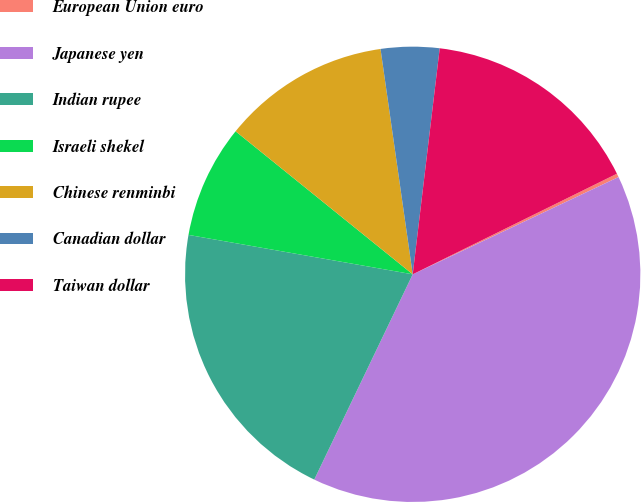<chart> <loc_0><loc_0><loc_500><loc_500><pie_chart><fcel>European Union euro<fcel>Japanese yen<fcel>Indian rupee<fcel>Israeli shekel<fcel>Chinese renminbi<fcel>Canadian dollar<fcel>Taiwan dollar<nl><fcel>0.26%<fcel>39.14%<fcel>20.65%<fcel>8.04%<fcel>11.93%<fcel>4.15%<fcel>15.82%<nl></chart> 